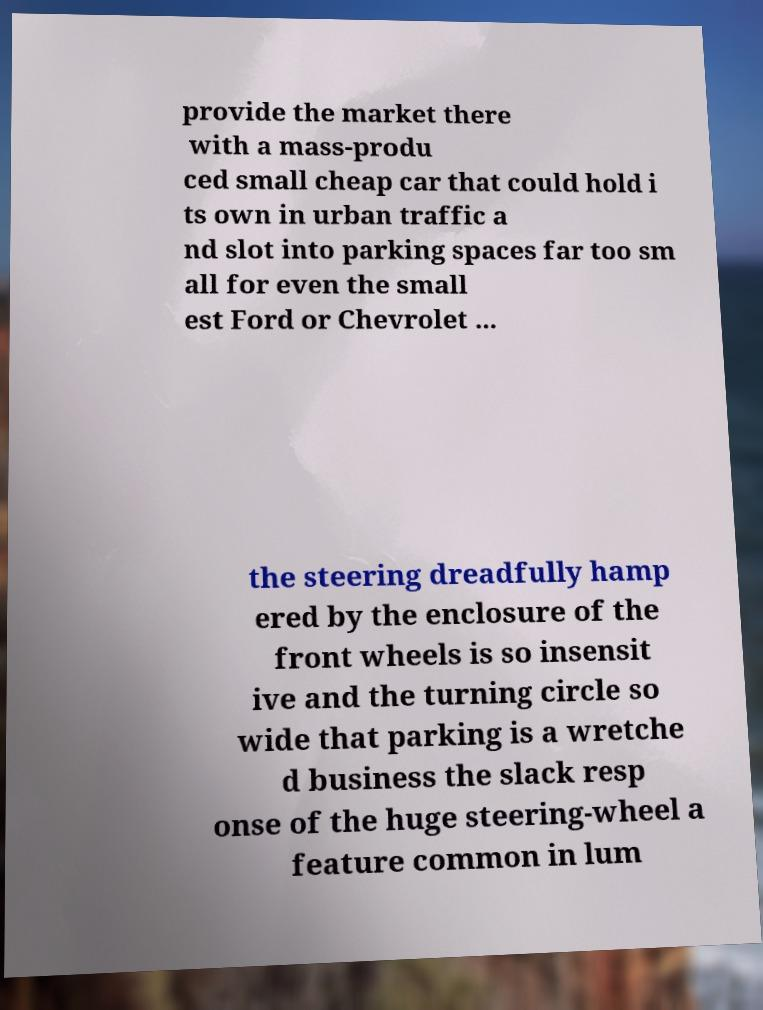Can you read and provide the text displayed in the image?This photo seems to have some interesting text. Can you extract and type it out for me? provide the market there with a mass-produ ced small cheap car that could hold i ts own in urban traffic a nd slot into parking spaces far too sm all for even the small est Ford or Chevrolet ... the steering dreadfully hamp ered by the enclosure of the front wheels is so insensit ive and the turning circle so wide that parking is a wretche d business the slack resp onse of the huge steering-wheel a feature common in lum 